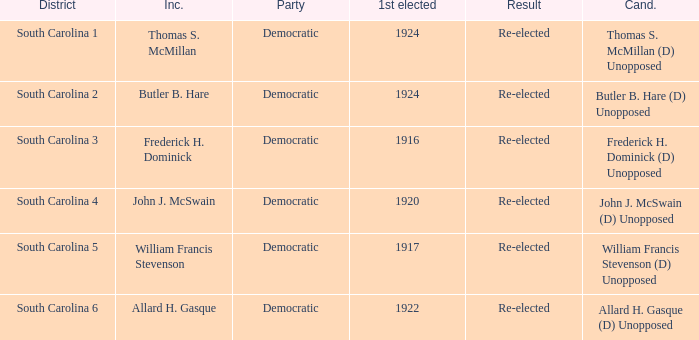Name the candidate for south carolina 1? Thomas S. McMillan (D) Unopposed. 